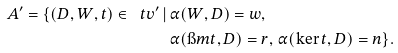Convert formula to latex. <formula><loc_0><loc_0><loc_500><loc_500>\ A ^ { \prime } = \{ ( D , W , t ) \in \ t v ^ { \prime } \, | \, & \alpha ( W , D ) = w , \\ & \alpha ( \i m t , D ) = r , \, \alpha ( \ker t , D ) = n \} .</formula> 